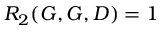Convert formula to latex. <formula><loc_0><loc_0><loc_500><loc_500>R _ { 2 } ( G , G , D ) = 1</formula> 